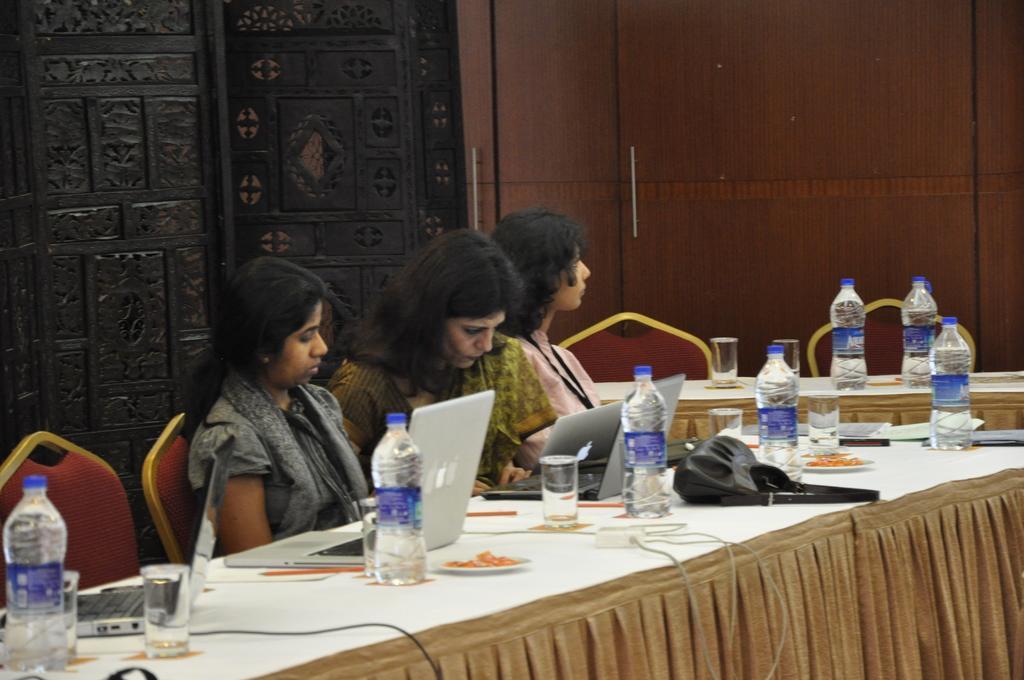Please provide a concise description of this image. In this image i can see 3 women sitting on chairs in front of a table. On the table i can see laptops, water bottles, water glasses, plates and a bag. In the background i can see a door and wooden wall. 